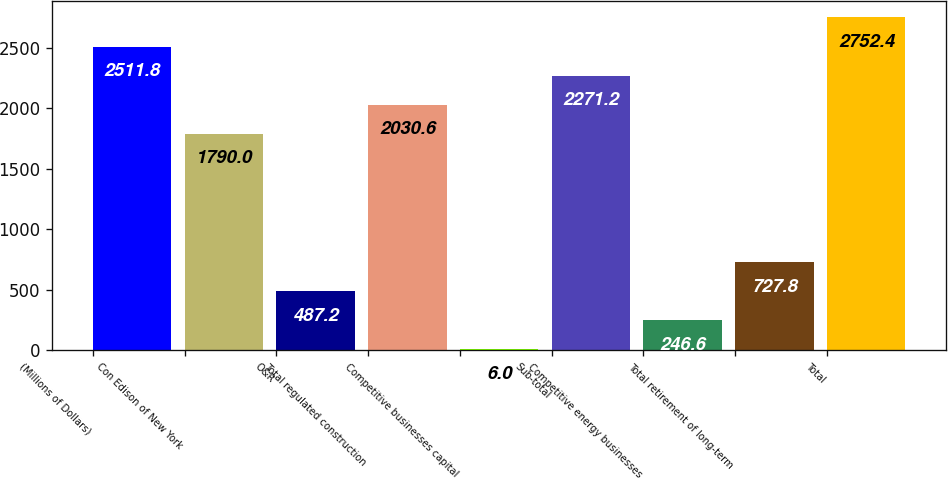Convert chart to OTSL. <chart><loc_0><loc_0><loc_500><loc_500><bar_chart><fcel>(Millions of Dollars)<fcel>Con Edison of New York<fcel>O&R<fcel>Total regulated construction<fcel>Competitive businesses capital<fcel>Sub-total<fcel>Competitive energy businesses<fcel>Total retirement of long-term<fcel>Total<nl><fcel>2511.8<fcel>1790<fcel>487.2<fcel>2030.6<fcel>6<fcel>2271.2<fcel>246.6<fcel>727.8<fcel>2752.4<nl></chart> 